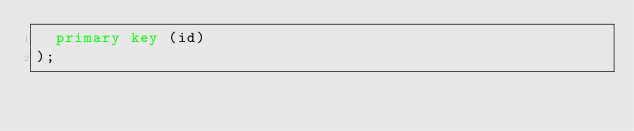Convert code to text. <code><loc_0><loc_0><loc_500><loc_500><_SQL_>  primary key (id)
);</code> 